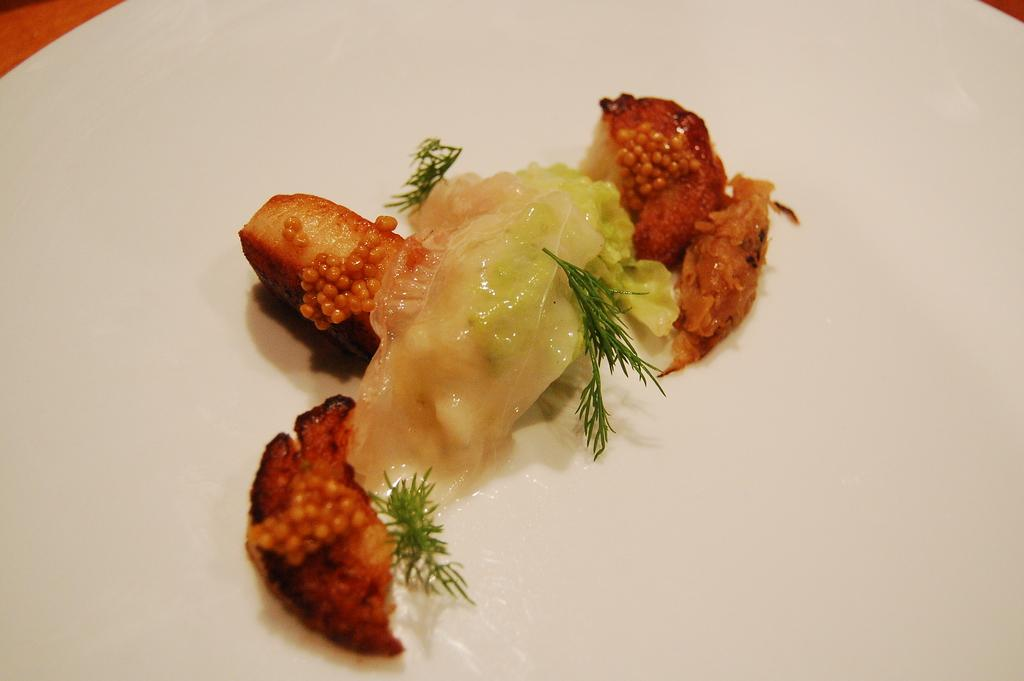What is on the plate that is visible in the image? There is food on a plate in the image. Where is the plate located in the image? The plate is placed on a table. Is the queen sitting on a bed in the image? There is no queen or bed present in the image; it only features a plate of food on a table. 